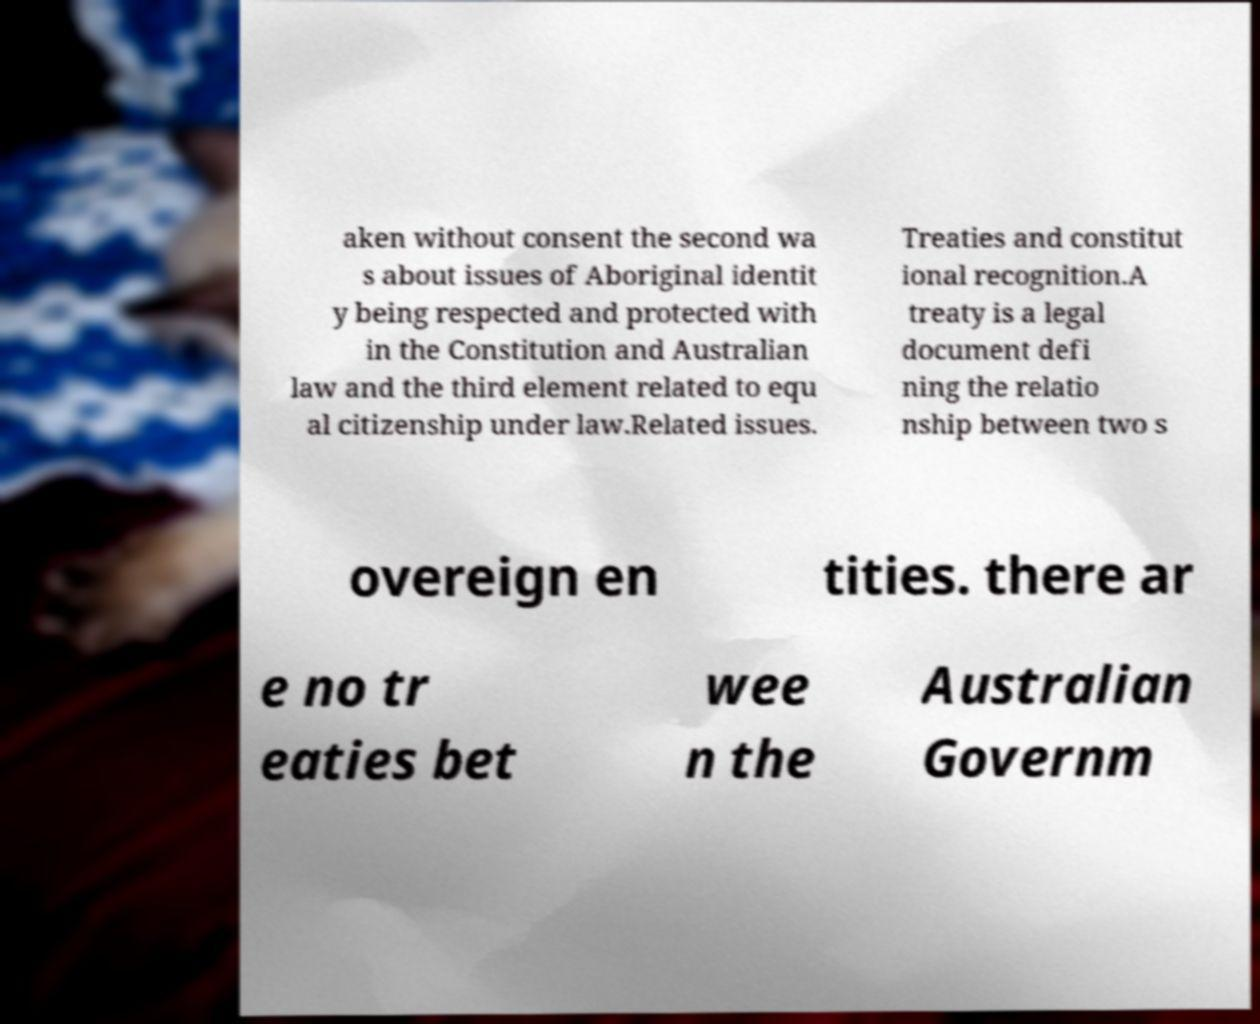I need the written content from this picture converted into text. Can you do that? aken without consent the second wa s about issues of Aboriginal identit y being respected and protected with in the Constitution and Australian law and the third element related to equ al citizenship under law.Related issues. Treaties and constitut ional recognition.A treaty is a legal document defi ning the relatio nship between two s overeign en tities. there ar e no tr eaties bet wee n the Australian Governm 